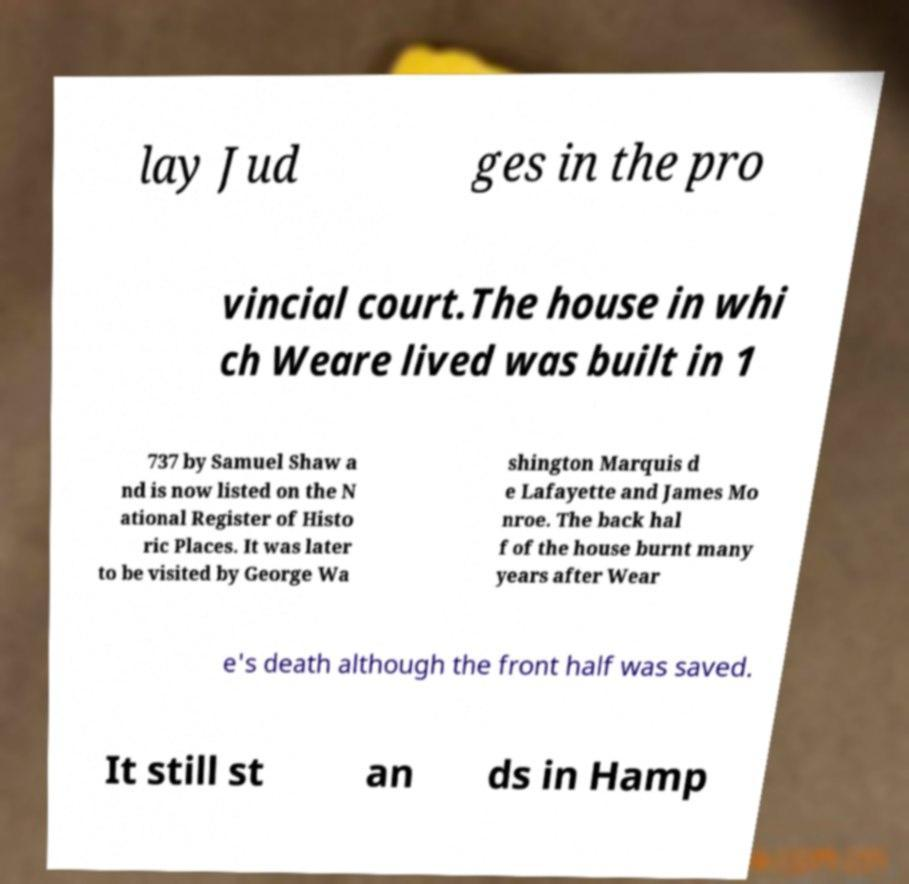There's text embedded in this image that I need extracted. Can you transcribe it verbatim? lay Jud ges in the pro vincial court.The house in whi ch Weare lived was built in 1 737 by Samuel Shaw a nd is now listed on the N ational Register of Histo ric Places. It was later to be visited by George Wa shington Marquis d e Lafayette and James Mo nroe. The back hal f of the house burnt many years after Wear e's death although the front half was saved. It still st an ds in Hamp 